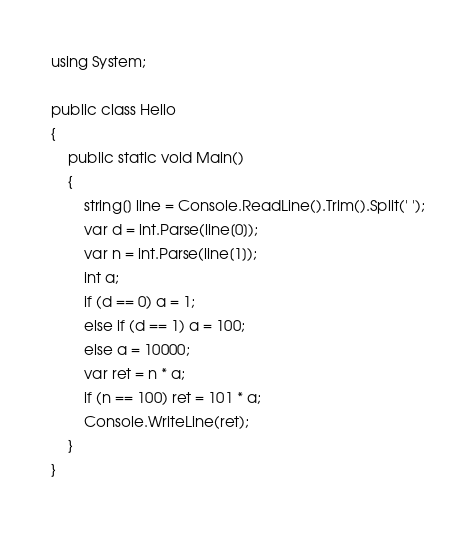<code> <loc_0><loc_0><loc_500><loc_500><_C#_>using System;

public class Hello
{
    public static void Main()
    {
        string[] line = Console.ReadLine().Trim().Split(' ');
        var d = int.Parse(line[0]);
        var n = int.Parse(line[1]);
        int a;
        if (d == 0) a = 1;
        else if (d == 1) a = 100;
        else a = 10000;
        var ret = n * a;
        if (n == 100) ret = 101 * a;
        Console.WriteLine(ret);
    }
}</code> 